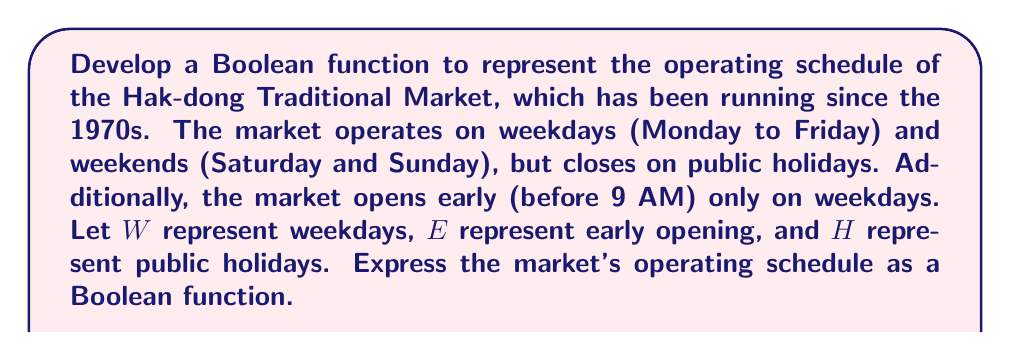Can you answer this question? Let's approach this step-by-step:

1) First, we need to define our variables:
   W: Weekday (1 if it's a weekday, 0 if it's a weekend)
   E: Early opening (1 if it's before 9 AM, 0 if it's after 9 AM)
   H: Holiday (1 if it's a public holiday, 0 if it's not)

2) The market operates on all days except public holidays. This can be represented as:
   $\overline{H}$

3) The market opens early only on weekdays. This can be represented as:
   $W \cdot E$

4) The market operates normally (after 9 AM) on all days when it's open. This can be represented as:
   $\overline{H} \cdot \overline{E}$

5) Combining these conditions using the OR operation (since the market is open if any of these conditions are true):

   $F(W,E,H) = (W \cdot E) + (\overline{H} \cdot \overline{E})$

6) This can be simplified using Boolean algebra:
   $F(W,E,H) = (W \cdot E) + (\overline{H} \cdot \overline{E})$
   $= (W \cdot E) + \overline{H} - (\overline{H} \cdot E)$  (using $A + B = A + \overline{A}B$)
   $= (W + \overline{H}) \cdot E + \overline{H}$  (using distributive law)

Therefore, the final Boolean function representing the market's operating schedule is:

$$F(W,E,H) = (W + \overline{H}) \cdot E + \overline{H}$$
Answer: $(W + \overline{H}) \cdot E + \overline{H}$ 